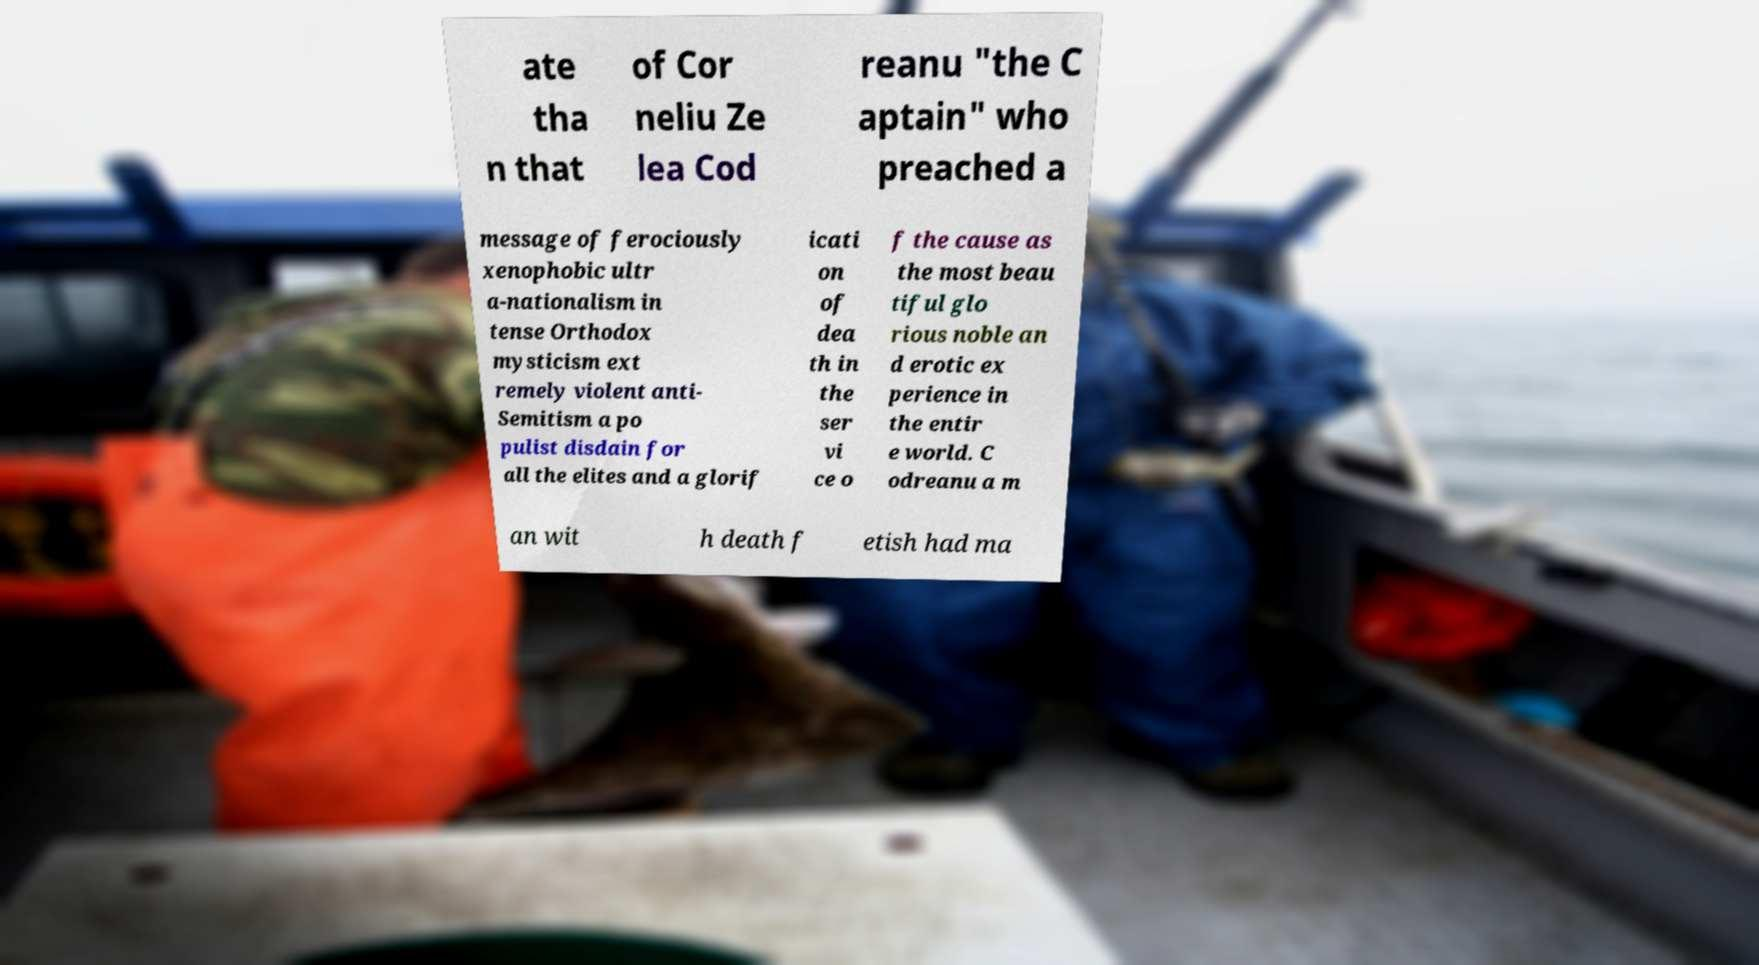What messages or text are displayed in this image? I need them in a readable, typed format. ate tha n that of Cor neliu Ze lea Cod reanu "the C aptain" who preached a message of ferociously xenophobic ultr a-nationalism in tense Orthodox mysticism ext remely violent anti- Semitism a po pulist disdain for all the elites and a glorif icati on of dea th in the ser vi ce o f the cause as the most beau tiful glo rious noble an d erotic ex perience in the entir e world. C odreanu a m an wit h death f etish had ma 